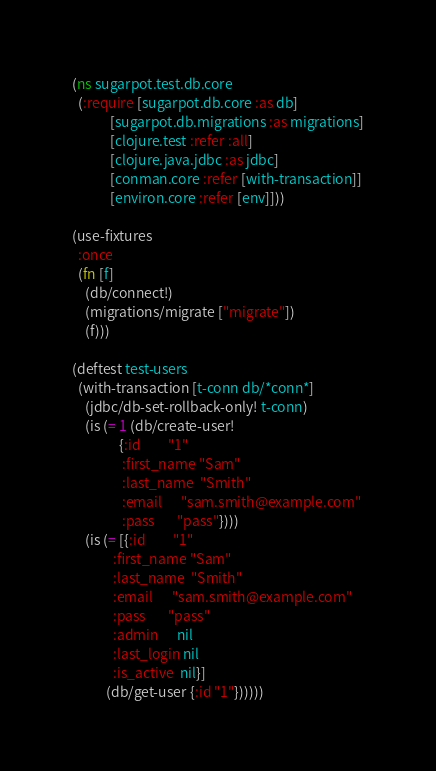<code> <loc_0><loc_0><loc_500><loc_500><_Clojure_>(ns sugarpot.test.db.core
  (:require [sugarpot.db.core :as db]
            [sugarpot.db.migrations :as migrations]
            [clojure.test :refer :all]
            [clojure.java.jdbc :as jdbc]
            [conman.core :refer [with-transaction]]
            [environ.core :refer [env]]))

(use-fixtures
  :once
  (fn [f]
    (db/connect!)
    (migrations/migrate ["migrate"])
    (f)))

(deftest test-users
  (with-transaction [t-conn db/*conn*]
    (jdbc/db-set-rollback-only! t-conn)
    (is (= 1 (db/create-user!
               {:id         "1"
                :first_name "Sam"
                :last_name  "Smith"
                :email      "sam.smith@example.com"
                :pass       "pass"})))
    (is (= [{:id         "1"
             :first_name "Sam"
             :last_name  "Smith"
             :email      "sam.smith@example.com"
             :pass       "pass"
             :admin      nil
             :last_login nil
             :is_active  nil}]
           (db/get-user {:id "1"})))))
</code> 